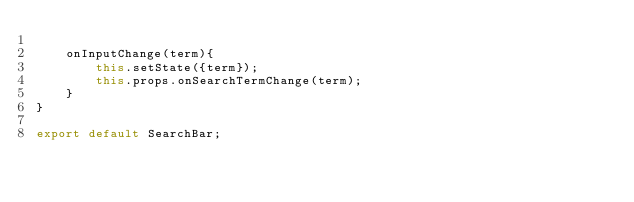Convert code to text. <code><loc_0><loc_0><loc_500><loc_500><_JavaScript_>
    onInputChange(term){
        this.setState({term});
        this.props.onSearchTermChange(term);
    }
}

export default SearchBar;</code> 